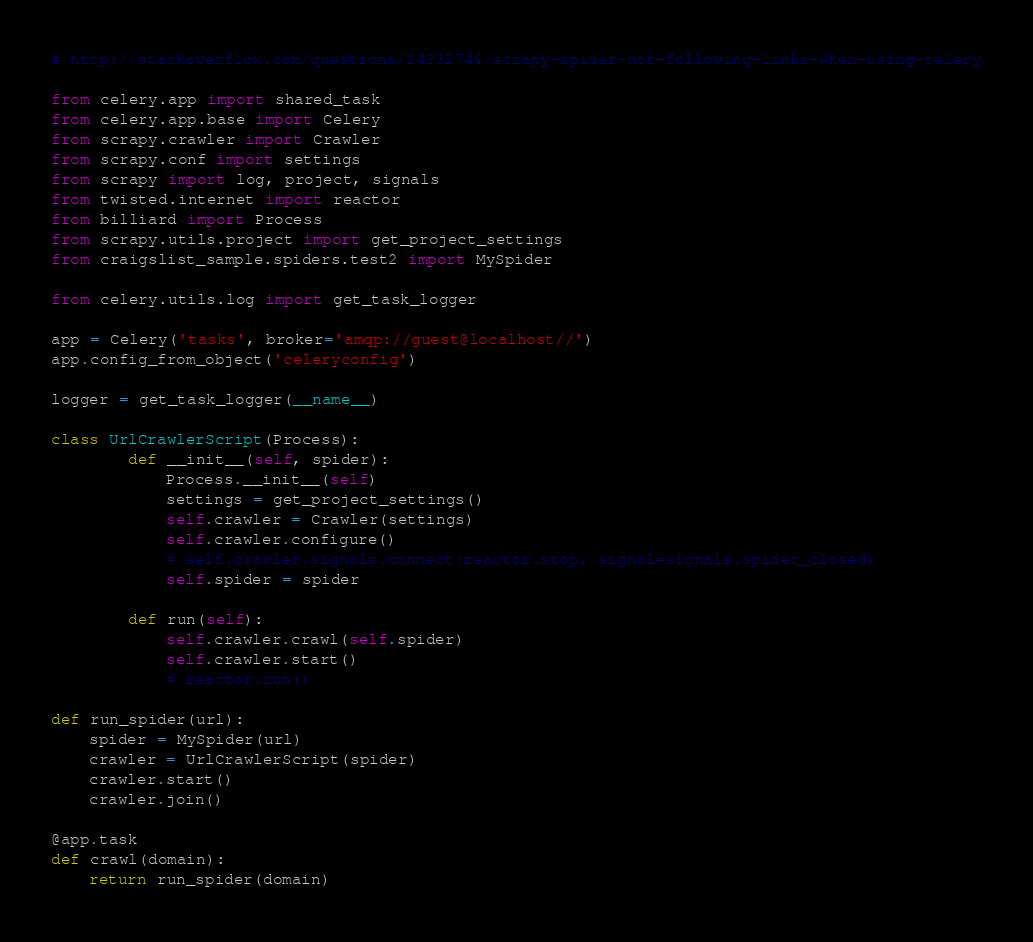<code> <loc_0><loc_0><loc_500><loc_500><_Python_># http://stackoverflow.com/questions/24232744/scrapy-spider-not-following-links-when-using-celery

from celery.app import shared_task
from celery.app.base import Celery
from scrapy.crawler import Crawler
from scrapy.conf import settings
from scrapy import log, project, signals
from twisted.internet import reactor
from billiard import Process
from scrapy.utils.project import get_project_settings
from craigslist_sample.spiders.test2 import MySpider

from celery.utils.log import get_task_logger

app = Celery('tasks', broker='amqp://guest@localhost//')
app.config_from_object('celeryconfig')

logger = get_task_logger(__name__)

class UrlCrawlerScript(Process):
        def __init__(self, spider):
            Process.__init__(self)
            settings = get_project_settings()
            self.crawler = Crawler(settings)
            self.crawler.configure()
            # self.crawler.signals.connect(reactor.stop, signal=signals.spider_closed)
            self.spider = spider

        def run(self):
            self.crawler.crawl(self.spider)
            self.crawler.start()
            # reactor.run()

def run_spider(url):
    spider = MySpider(url)
    crawler = UrlCrawlerScript(spider)
    crawler.start()
    crawler.join()

@app.task
def crawl(domain):
    return run_spider(domain)</code> 